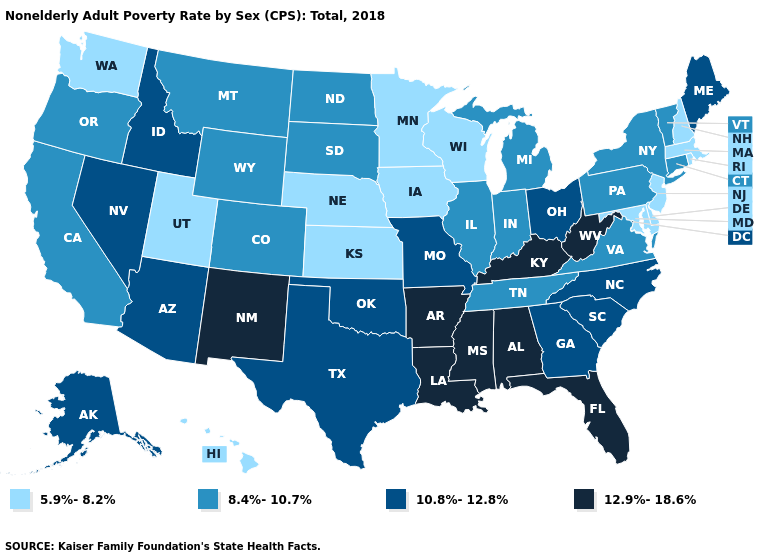Which states have the highest value in the USA?
Answer briefly. Alabama, Arkansas, Florida, Kentucky, Louisiana, Mississippi, New Mexico, West Virginia. Does Maine have a lower value than New Mexico?
Give a very brief answer. Yes. Does North Dakota have the same value as Arkansas?
Keep it brief. No. Does Washington have the lowest value in the West?
Give a very brief answer. Yes. Among the states that border Kansas , which have the highest value?
Be succinct. Missouri, Oklahoma. What is the value of Colorado?
Short answer required. 8.4%-10.7%. How many symbols are there in the legend?
Short answer required. 4. Among the states that border Idaho , which have the highest value?
Short answer required. Nevada. Name the states that have a value in the range 8.4%-10.7%?
Concise answer only. California, Colorado, Connecticut, Illinois, Indiana, Michigan, Montana, New York, North Dakota, Oregon, Pennsylvania, South Dakota, Tennessee, Vermont, Virginia, Wyoming. Among the states that border Oregon , which have the lowest value?
Short answer required. Washington. What is the value of Pennsylvania?
Write a very short answer. 8.4%-10.7%. What is the value of Wisconsin?
Keep it brief. 5.9%-8.2%. Which states hav the highest value in the Northeast?
Quick response, please. Maine. Name the states that have a value in the range 12.9%-18.6%?
Short answer required. Alabama, Arkansas, Florida, Kentucky, Louisiana, Mississippi, New Mexico, West Virginia. Does New Mexico have the highest value in the West?
Quick response, please. Yes. 